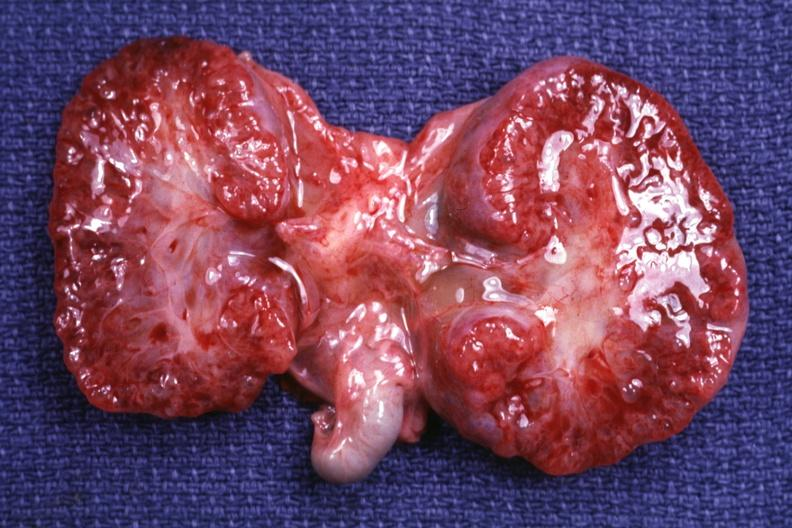what does this image show?
Answer the question using a single word or phrase. Cut surface both kidneys 